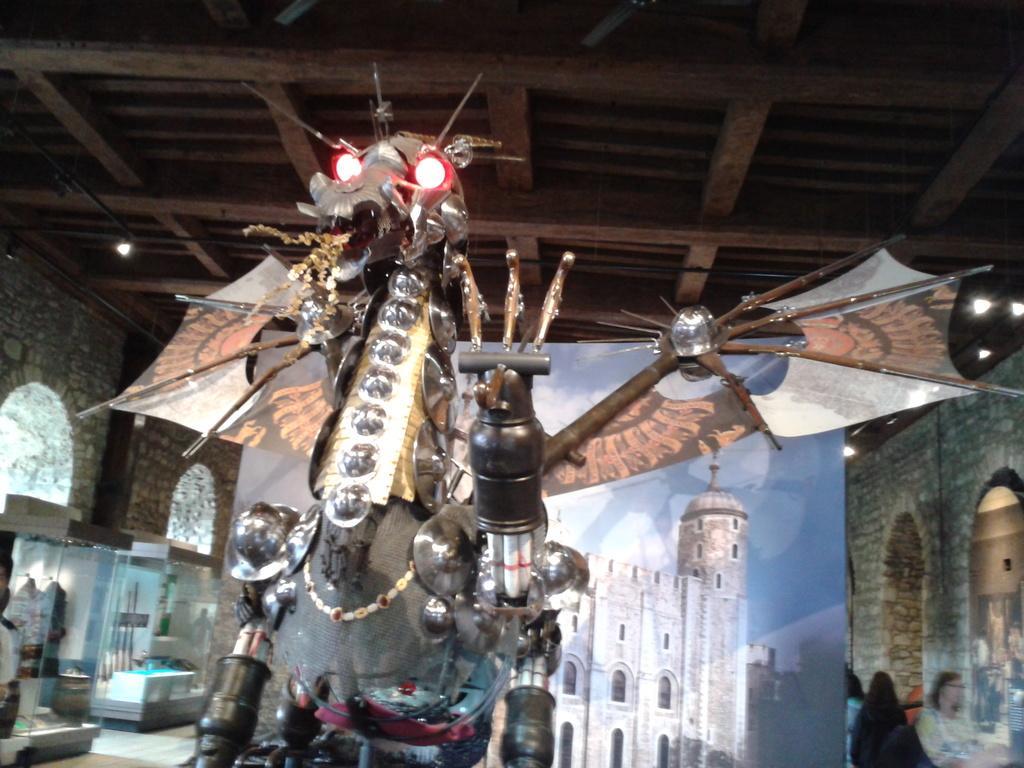Could you give a brief overview of what you see in this image? In this image I can see the an animal statue. In the background I can see group of people standing. In the screen I can also see the building in cream color and the sky is in blue color and I can also see few objects in the glass box. 